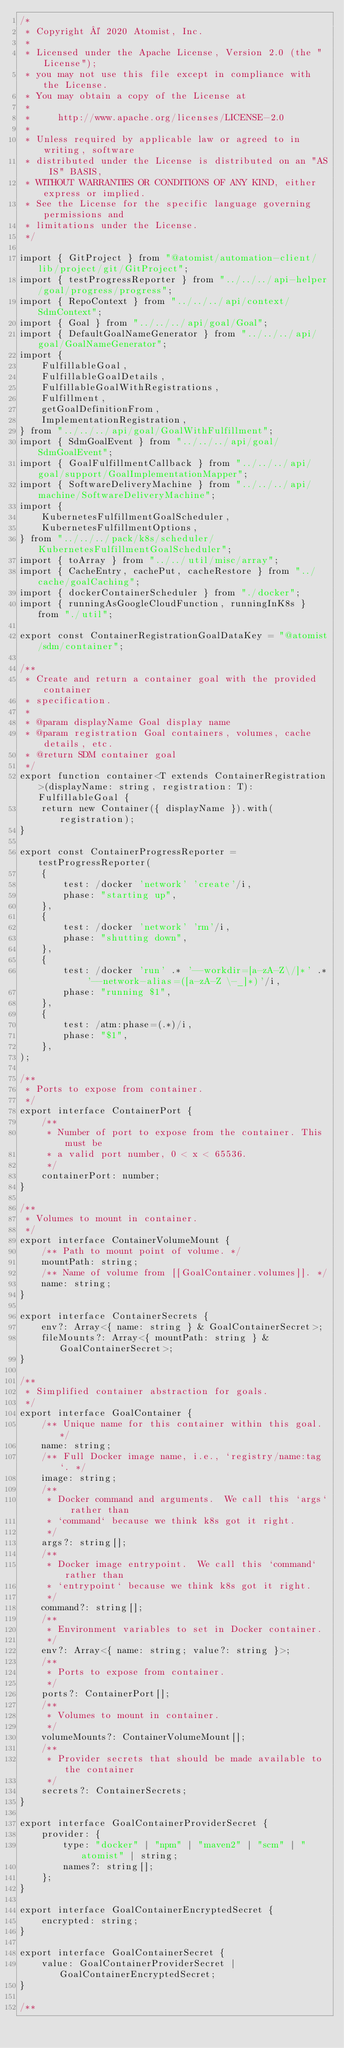Convert code to text. <code><loc_0><loc_0><loc_500><loc_500><_TypeScript_>/*
 * Copyright © 2020 Atomist, Inc.
 *
 * Licensed under the Apache License, Version 2.0 (the "License");
 * you may not use this file except in compliance with the License.
 * You may obtain a copy of the License at
 *
 *     http://www.apache.org/licenses/LICENSE-2.0
 *
 * Unless required by applicable law or agreed to in writing, software
 * distributed under the License is distributed on an "AS IS" BASIS,
 * WITHOUT WARRANTIES OR CONDITIONS OF ANY KIND, either express or implied.
 * See the License for the specific language governing permissions and
 * limitations under the License.
 */

import { GitProject } from "@atomist/automation-client/lib/project/git/GitProject";
import { testProgressReporter } from "../../../api-helper/goal/progress/progress";
import { RepoContext } from "../../../api/context/SdmContext";
import { Goal } from "../../../api/goal/Goal";
import { DefaultGoalNameGenerator } from "../../../api/goal/GoalNameGenerator";
import {
    FulfillableGoal,
    FulfillableGoalDetails,
    FulfillableGoalWithRegistrations,
    Fulfillment,
    getGoalDefinitionFrom,
    ImplementationRegistration,
} from "../../../api/goal/GoalWithFulfillment";
import { SdmGoalEvent } from "../../../api/goal/SdmGoalEvent";
import { GoalFulfillmentCallback } from "../../../api/goal/support/GoalImplementationMapper";
import { SoftwareDeliveryMachine } from "../../../api/machine/SoftwareDeliveryMachine";
import {
    KubernetesFulfillmentGoalScheduler,
    KubernetesFulfillmentOptions,
} from "../../../pack/k8s/scheduler/KubernetesFulfillmentGoalScheduler";
import { toArray } from "../../util/misc/array";
import { CacheEntry, cachePut, cacheRestore } from "../cache/goalCaching";
import { dockerContainerScheduler } from "./docker";
import { runningAsGoogleCloudFunction, runningInK8s } from "./util";

export const ContainerRegistrationGoalDataKey = "@atomist/sdm/container";

/**
 * Create and return a container goal with the provided container
 * specification.
 *
 * @param displayName Goal display name
 * @param registration Goal containers, volumes, cache details, etc.
 * @return SDM container goal
 */
export function container<T extends ContainerRegistration>(displayName: string, registration: T): FulfillableGoal {
    return new Container({ displayName }).with(registration);
}

export const ContainerProgressReporter = testProgressReporter(
    {
        test: /docker 'network' 'create'/i,
        phase: "starting up",
    },
    {
        test: /docker 'network' 'rm'/i,
        phase: "shutting down",
    },
    {
        test: /docker 'run' .* '--workdir=[a-zA-Z\/]*' .* '--network-alias=([a-zA-Z \-_]*)'/i,
        phase: "running $1",
    },
    {
        test: /atm:phase=(.*)/i,
        phase: "$1",
    },
);

/**
 * Ports to expose from container.
 */
export interface ContainerPort {
    /**
     * Number of port to expose from the container. This must be
     * a valid port number, 0 < x < 65536.
     */
    containerPort: number;
}

/**
 * Volumes to mount in container.
 */
export interface ContainerVolumeMount {
    /** Path to mount point of volume. */
    mountPath: string;
    /** Name of volume from [[GoalContainer.volumes]]. */
    name: string;
}

export interface ContainerSecrets {
    env?: Array<{ name: string } & GoalContainerSecret>;
    fileMounts?: Array<{ mountPath: string } & GoalContainerSecret>;
}

/**
 * Simplified container abstraction for goals.
 */
export interface GoalContainer {
    /** Unique name for this container within this goal. */
    name: string;
    /** Full Docker image name, i.e., `registry/name:tag`. */
    image: string;
    /**
     * Docker command and arguments.  We call this `args` rather than
     * `command` because we think k8s got it right.
     */
    args?: string[];
    /**
     * Docker image entrypoint.  We call this `command` rather than
     * `entrypoint` because we think k8s got it right.
     */
    command?: string[];
    /**
     * Environment variables to set in Docker container.
     */
    env?: Array<{ name: string; value?: string }>;
    /**
     * Ports to expose from container.
     */
    ports?: ContainerPort[];
    /**
     * Volumes to mount in container.
     */
    volumeMounts?: ContainerVolumeMount[];
    /**
     * Provider secrets that should be made available to the container
     */
    secrets?: ContainerSecrets;
}

export interface GoalContainerProviderSecret {
    provider: {
        type: "docker" | "npm" | "maven2" | "scm" | "atomist" | string;
        names?: string[];
    };
}

export interface GoalContainerEncryptedSecret {
    encrypted: string;
}

export interface GoalContainerSecret {
    value: GoalContainerProviderSecret | GoalContainerEncryptedSecret;
}

/**</code> 